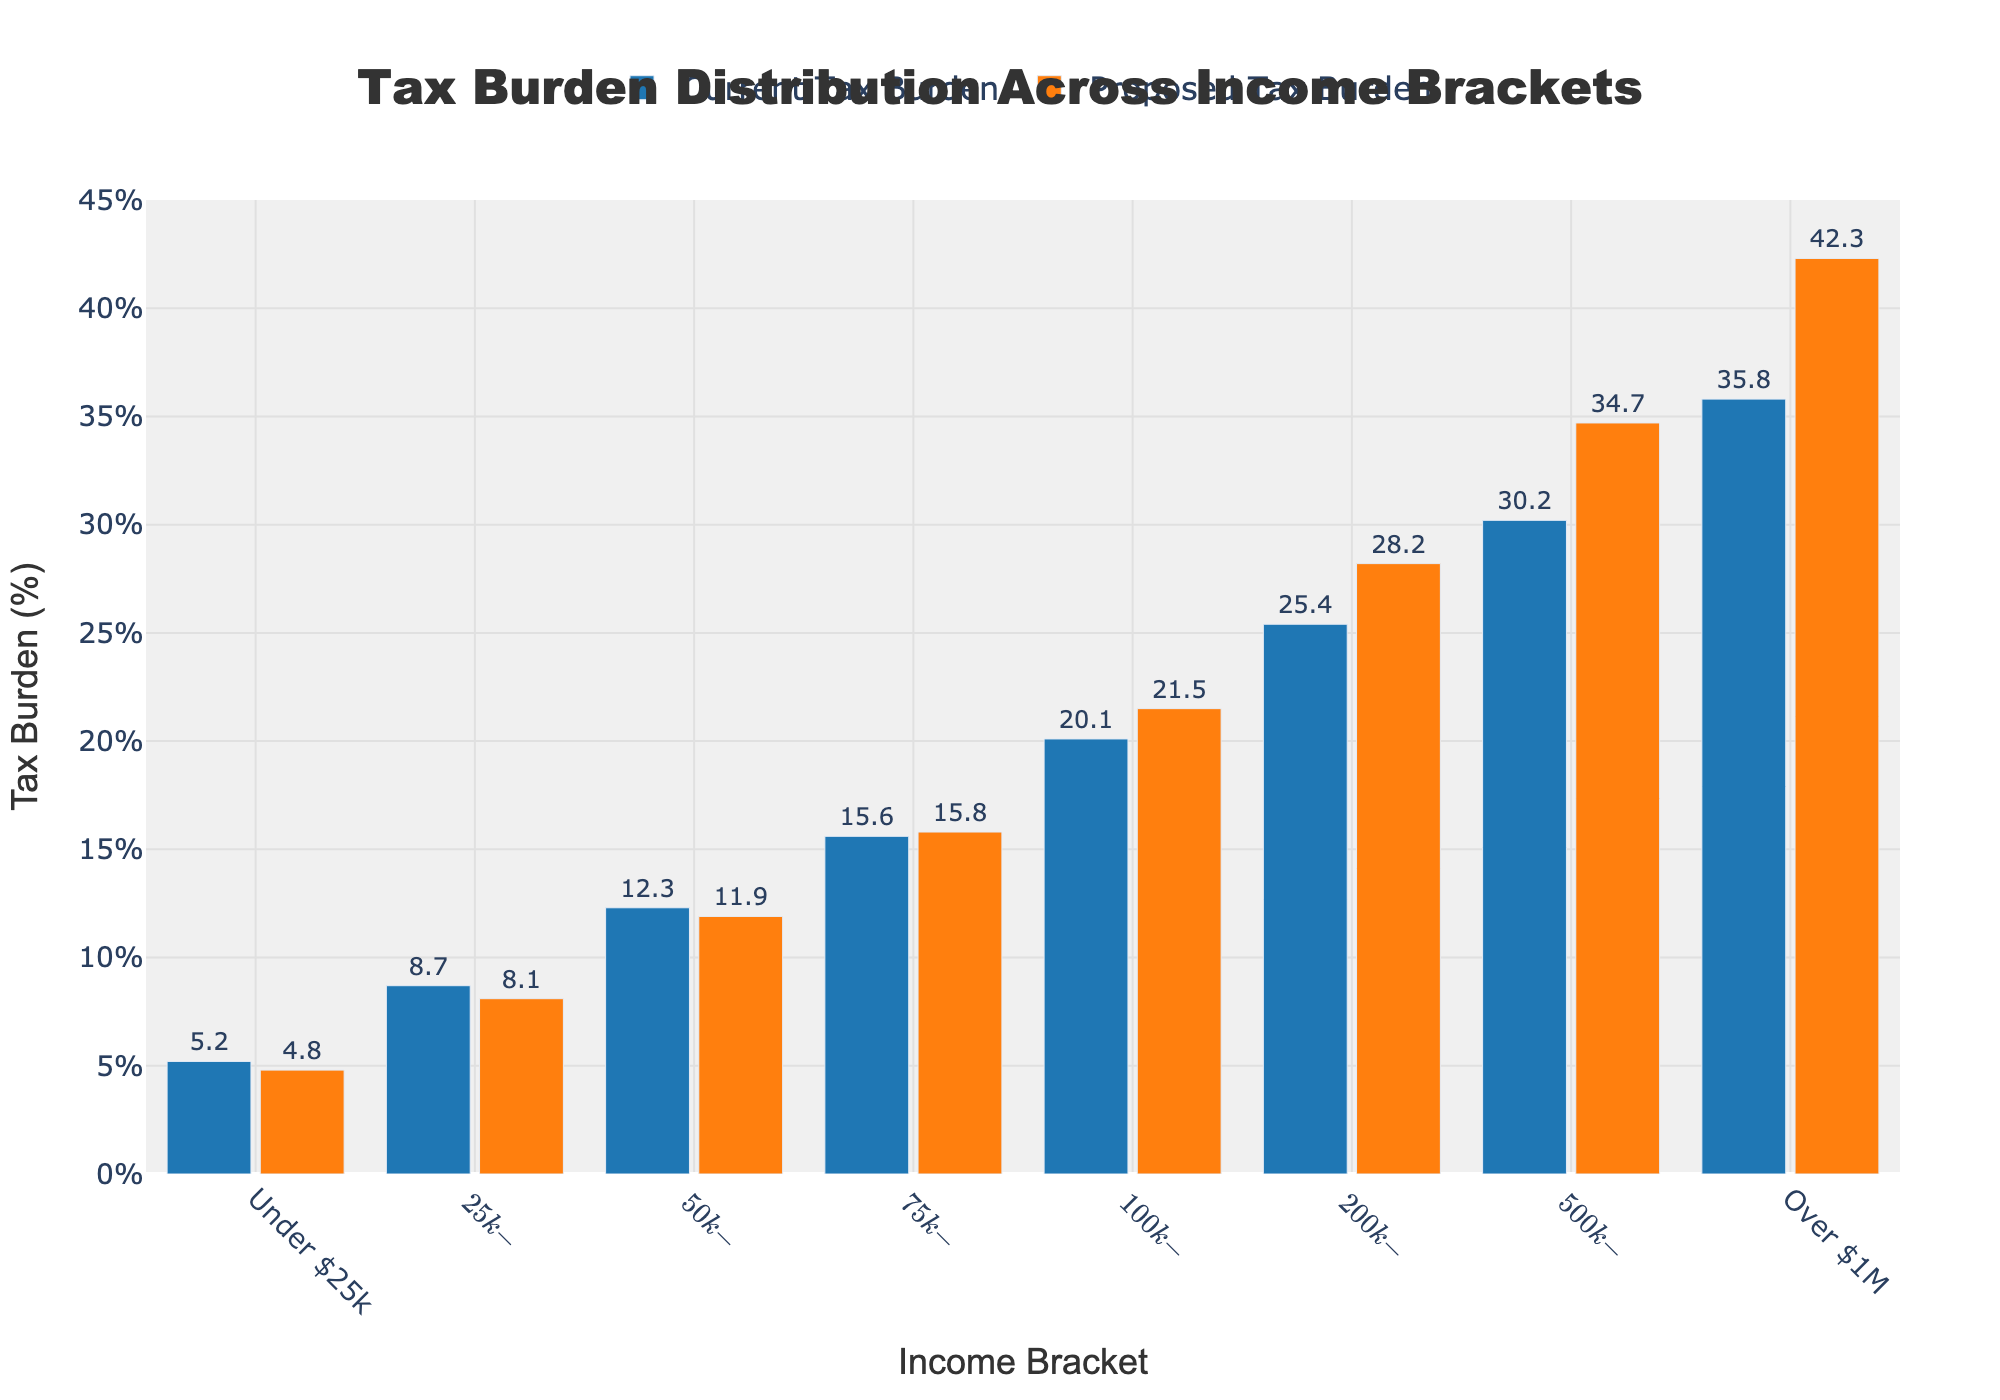What is the difference in tax burden for the "$25k-$50k" income bracket between the current and proposed policies? To find the difference in the tax burden for the "$25k-$50k" income bracket, subtract the proposed tax burden from the current tax burden: 8.7% - 8.1% = 0.6%.
Answer: 0.6% Which income bracket sees the highest increase in tax burden under the proposed policies compared to the current policy? To determine which bracket sees the highest increase, compare the differences between the proposed and current tax burdens. The largest difference occurs in the "Over $1M" bracket: 42.3% - 35.8% = 6.5%.
Answer: Over $1M What is the combined tax burden (current) for the brackets "$100k-$200k" and "$200k-$500k"? Add the current tax burdens for the "$100k-$200k" and "$200k-$500k" brackets: 20.1% + 25.4% = 45.5%.
Answer: 45.5% Which income bracket has a lower tax burden in the proposed policy compared to the current policy? Identify the bar where the proposed tax burden is lower than the current tax burden. For the "Under $25k" bracket, it is 5.2% (current) versus 4.8% (proposed), and for the "$25k-$50k" bracket, it is 8.7% (current) versus 8.1% (proposed).
Answer: Under $25k, $25k-$50k What is the average increase in tax burden for income brackets "$200k-$500k", "$500k-$1M", and "Over $1M" under the proposed policy? First, calculate the differences for each bracket: 
"$200k-$500k": 28.2% - 25.4% = 2.8%, 
"$500k-$1M": 34.7% - 30.2% = 4.5%, 
"Over $1M": 42.3% - 35.8% = 6.5%. 
Then, find the average: (2.8% + 4.5% + 6.5%) / 3 = 4.6%.
Answer: 4.6% For the income bracket "$75k-$100k," how does the proposed policy tax burden compare to the current policy tax burden visually? Visually compare the heights of the bars for the "$75k-$100k" bracket. The proposed tax burden bar is slightly higher than the current tax burden bar.
Answer: Slightly higher Which income bracket has an equal tax burden change from the current to the proposed policy? Compare the differences between the current and proposed tax burdens. The "Under $25k" and "$25k-$50k" brackets both experience an equal decrease (-0.4% and -0.6% respectively), but since the question asks for equal burden change directly, there's no bracket with equal tax burden change exactly.
Answer: None 